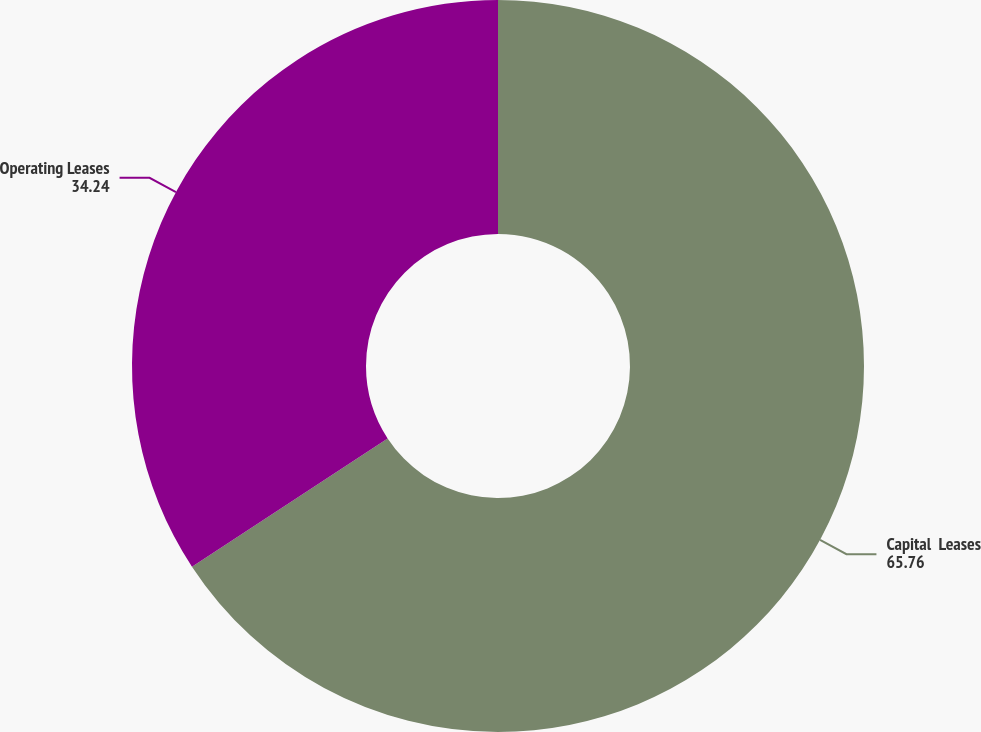<chart> <loc_0><loc_0><loc_500><loc_500><pie_chart><fcel>Capital  Leases<fcel>Operating Leases<nl><fcel>65.76%<fcel>34.24%<nl></chart> 